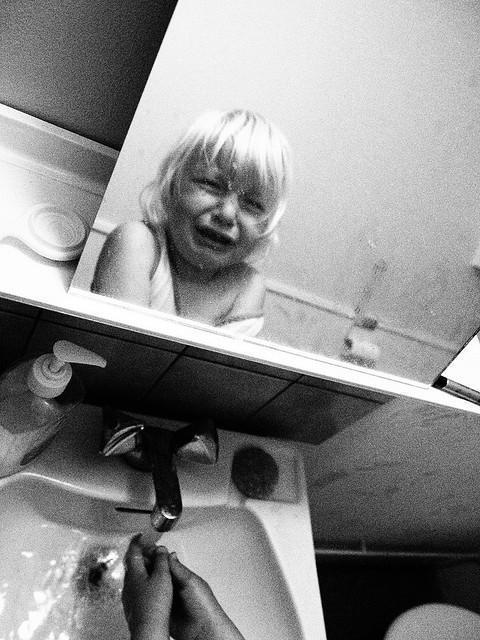How many people can be seen?
Give a very brief answer. 2. 